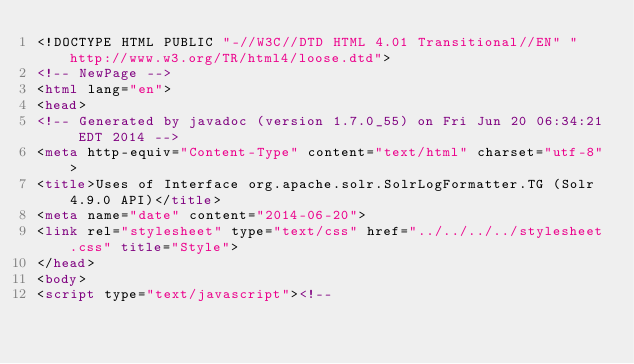<code> <loc_0><loc_0><loc_500><loc_500><_HTML_><!DOCTYPE HTML PUBLIC "-//W3C//DTD HTML 4.01 Transitional//EN" "http://www.w3.org/TR/html4/loose.dtd">
<!-- NewPage -->
<html lang="en">
<head>
<!-- Generated by javadoc (version 1.7.0_55) on Fri Jun 20 06:34:21 EDT 2014 -->
<meta http-equiv="Content-Type" content="text/html" charset="utf-8">
<title>Uses of Interface org.apache.solr.SolrLogFormatter.TG (Solr 4.9.0 API)</title>
<meta name="date" content="2014-06-20">
<link rel="stylesheet" type="text/css" href="../../../../stylesheet.css" title="Style">
</head>
<body>
<script type="text/javascript"><!--</code> 